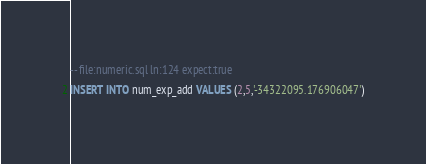Convert code to text. <code><loc_0><loc_0><loc_500><loc_500><_SQL_>-- file:numeric.sql ln:124 expect:true
INSERT INTO num_exp_add VALUES (2,5,'-34322095.176906047')
</code> 